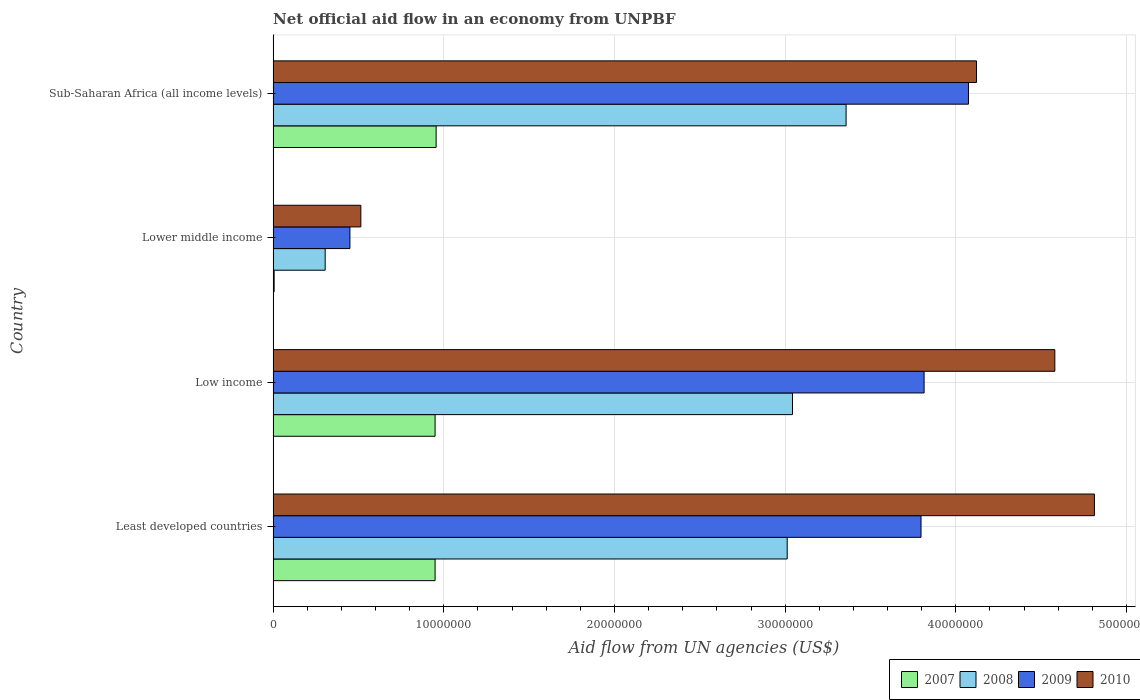How many groups of bars are there?
Your answer should be compact. 4. Are the number of bars per tick equal to the number of legend labels?
Offer a terse response. Yes. In how many cases, is the number of bars for a given country not equal to the number of legend labels?
Offer a very short reply. 0. What is the net official aid flow in 2008 in Least developed countries?
Your response must be concise. 3.01e+07. Across all countries, what is the maximum net official aid flow in 2007?
Provide a short and direct response. 9.55e+06. In which country was the net official aid flow in 2008 maximum?
Offer a terse response. Sub-Saharan Africa (all income levels). In which country was the net official aid flow in 2007 minimum?
Ensure brevity in your answer.  Lower middle income. What is the total net official aid flow in 2007 in the graph?
Your answer should be very brief. 2.86e+07. What is the difference between the net official aid flow in 2009 in Low income and that in Sub-Saharan Africa (all income levels)?
Make the answer very short. -2.60e+06. What is the difference between the net official aid flow in 2007 in Least developed countries and the net official aid flow in 2009 in Low income?
Your response must be concise. -2.86e+07. What is the average net official aid flow in 2010 per country?
Your answer should be very brief. 3.51e+07. What is the difference between the net official aid flow in 2007 and net official aid flow in 2008 in Sub-Saharan Africa (all income levels)?
Make the answer very short. -2.40e+07. What is the ratio of the net official aid flow in 2010 in Least developed countries to that in Lower middle income?
Offer a terse response. 9.36. Is the net official aid flow in 2007 in Least developed countries less than that in Sub-Saharan Africa (all income levels)?
Give a very brief answer. Yes. Is the difference between the net official aid flow in 2007 in Least developed countries and Sub-Saharan Africa (all income levels) greater than the difference between the net official aid flow in 2008 in Least developed countries and Sub-Saharan Africa (all income levels)?
Keep it short and to the point. Yes. What is the difference between the highest and the second highest net official aid flow in 2010?
Offer a terse response. 2.32e+06. What is the difference between the highest and the lowest net official aid flow in 2009?
Offer a terse response. 3.62e+07. In how many countries, is the net official aid flow in 2010 greater than the average net official aid flow in 2010 taken over all countries?
Offer a terse response. 3. Is it the case that in every country, the sum of the net official aid flow in 2009 and net official aid flow in 2010 is greater than the sum of net official aid flow in 2008 and net official aid flow in 2007?
Give a very brief answer. No. What does the 2nd bar from the bottom in Least developed countries represents?
Offer a very short reply. 2008. Is it the case that in every country, the sum of the net official aid flow in 2009 and net official aid flow in 2010 is greater than the net official aid flow in 2008?
Provide a short and direct response. Yes. How many countries are there in the graph?
Your answer should be compact. 4. What is the difference between two consecutive major ticks on the X-axis?
Your answer should be compact. 1.00e+07. Does the graph contain grids?
Make the answer very short. Yes. How many legend labels are there?
Ensure brevity in your answer.  4. How are the legend labels stacked?
Your answer should be compact. Horizontal. What is the title of the graph?
Your answer should be compact. Net official aid flow in an economy from UNPBF. Does "1969" appear as one of the legend labels in the graph?
Make the answer very short. No. What is the label or title of the X-axis?
Offer a terse response. Aid flow from UN agencies (US$). What is the Aid flow from UN agencies (US$) of 2007 in Least developed countries?
Provide a succinct answer. 9.49e+06. What is the Aid flow from UN agencies (US$) of 2008 in Least developed countries?
Your response must be concise. 3.01e+07. What is the Aid flow from UN agencies (US$) of 2009 in Least developed countries?
Offer a very short reply. 3.80e+07. What is the Aid flow from UN agencies (US$) in 2010 in Least developed countries?
Your answer should be very brief. 4.81e+07. What is the Aid flow from UN agencies (US$) of 2007 in Low income?
Offer a very short reply. 9.49e+06. What is the Aid flow from UN agencies (US$) of 2008 in Low income?
Offer a very short reply. 3.04e+07. What is the Aid flow from UN agencies (US$) in 2009 in Low income?
Offer a terse response. 3.81e+07. What is the Aid flow from UN agencies (US$) in 2010 in Low income?
Your response must be concise. 4.58e+07. What is the Aid flow from UN agencies (US$) of 2007 in Lower middle income?
Make the answer very short. 6.00e+04. What is the Aid flow from UN agencies (US$) of 2008 in Lower middle income?
Offer a terse response. 3.05e+06. What is the Aid flow from UN agencies (US$) in 2009 in Lower middle income?
Provide a short and direct response. 4.50e+06. What is the Aid flow from UN agencies (US$) in 2010 in Lower middle income?
Your response must be concise. 5.14e+06. What is the Aid flow from UN agencies (US$) in 2007 in Sub-Saharan Africa (all income levels)?
Keep it short and to the point. 9.55e+06. What is the Aid flow from UN agencies (US$) of 2008 in Sub-Saharan Africa (all income levels)?
Give a very brief answer. 3.36e+07. What is the Aid flow from UN agencies (US$) in 2009 in Sub-Saharan Africa (all income levels)?
Provide a succinct answer. 4.07e+07. What is the Aid flow from UN agencies (US$) of 2010 in Sub-Saharan Africa (all income levels)?
Offer a very short reply. 4.12e+07. Across all countries, what is the maximum Aid flow from UN agencies (US$) in 2007?
Your answer should be very brief. 9.55e+06. Across all countries, what is the maximum Aid flow from UN agencies (US$) in 2008?
Provide a short and direct response. 3.36e+07. Across all countries, what is the maximum Aid flow from UN agencies (US$) of 2009?
Give a very brief answer. 4.07e+07. Across all countries, what is the maximum Aid flow from UN agencies (US$) in 2010?
Keep it short and to the point. 4.81e+07. Across all countries, what is the minimum Aid flow from UN agencies (US$) of 2007?
Provide a succinct answer. 6.00e+04. Across all countries, what is the minimum Aid flow from UN agencies (US$) of 2008?
Give a very brief answer. 3.05e+06. Across all countries, what is the minimum Aid flow from UN agencies (US$) in 2009?
Your answer should be very brief. 4.50e+06. Across all countries, what is the minimum Aid flow from UN agencies (US$) of 2010?
Give a very brief answer. 5.14e+06. What is the total Aid flow from UN agencies (US$) in 2007 in the graph?
Give a very brief answer. 2.86e+07. What is the total Aid flow from UN agencies (US$) of 2008 in the graph?
Your response must be concise. 9.72e+07. What is the total Aid flow from UN agencies (US$) of 2009 in the graph?
Keep it short and to the point. 1.21e+08. What is the total Aid flow from UN agencies (US$) in 2010 in the graph?
Provide a short and direct response. 1.40e+08. What is the difference between the Aid flow from UN agencies (US$) of 2008 in Least developed countries and that in Low income?
Your answer should be compact. -3.10e+05. What is the difference between the Aid flow from UN agencies (US$) in 2009 in Least developed countries and that in Low income?
Provide a short and direct response. -1.80e+05. What is the difference between the Aid flow from UN agencies (US$) of 2010 in Least developed countries and that in Low income?
Offer a terse response. 2.32e+06. What is the difference between the Aid flow from UN agencies (US$) of 2007 in Least developed countries and that in Lower middle income?
Offer a terse response. 9.43e+06. What is the difference between the Aid flow from UN agencies (US$) in 2008 in Least developed countries and that in Lower middle income?
Give a very brief answer. 2.71e+07. What is the difference between the Aid flow from UN agencies (US$) of 2009 in Least developed countries and that in Lower middle income?
Make the answer very short. 3.35e+07. What is the difference between the Aid flow from UN agencies (US$) in 2010 in Least developed countries and that in Lower middle income?
Provide a short and direct response. 4.30e+07. What is the difference between the Aid flow from UN agencies (US$) in 2007 in Least developed countries and that in Sub-Saharan Africa (all income levels)?
Provide a succinct answer. -6.00e+04. What is the difference between the Aid flow from UN agencies (US$) of 2008 in Least developed countries and that in Sub-Saharan Africa (all income levels)?
Provide a succinct answer. -3.45e+06. What is the difference between the Aid flow from UN agencies (US$) of 2009 in Least developed countries and that in Sub-Saharan Africa (all income levels)?
Your answer should be very brief. -2.78e+06. What is the difference between the Aid flow from UN agencies (US$) in 2010 in Least developed countries and that in Sub-Saharan Africa (all income levels)?
Provide a succinct answer. 6.91e+06. What is the difference between the Aid flow from UN agencies (US$) of 2007 in Low income and that in Lower middle income?
Your answer should be very brief. 9.43e+06. What is the difference between the Aid flow from UN agencies (US$) of 2008 in Low income and that in Lower middle income?
Provide a succinct answer. 2.74e+07. What is the difference between the Aid flow from UN agencies (US$) of 2009 in Low income and that in Lower middle income?
Provide a short and direct response. 3.36e+07. What is the difference between the Aid flow from UN agencies (US$) in 2010 in Low income and that in Lower middle income?
Give a very brief answer. 4.07e+07. What is the difference between the Aid flow from UN agencies (US$) in 2008 in Low income and that in Sub-Saharan Africa (all income levels)?
Your answer should be compact. -3.14e+06. What is the difference between the Aid flow from UN agencies (US$) of 2009 in Low income and that in Sub-Saharan Africa (all income levels)?
Make the answer very short. -2.60e+06. What is the difference between the Aid flow from UN agencies (US$) in 2010 in Low income and that in Sub-Saharan Africa (all income levels)?
Offer a terse response. 4.59e+06. What is the difference between the Aid flow from UN agencies (US$) of 2007 in Lower middle income and that in Sub-Saharan Africa (all income levels)?
Your response must be concise. -9.49e+06. What is the difference between the Aid flow from UN agencies (US$) in 2008 in Lower middle income and that in Sub-Saharan Africa (all income levels)?
Ensure brevity in your answer.  -3.05e+07. What is the difference between the Aid flow from UN agencies (US$) in 2009 in Lower middle income and that in Sub-Saharan Africa (all income levels)?
Provide a succinct answer. -3.62e+07. What is the difference between the Aid flow from UN agencies (US$) in 2010 in Lower middle income and that in Sub-Saharan Africa (all income levels)?
Offer a very short reply. -3.61e+07. What is the difference between the Aid flow from UN agencies (US$) of 2007 in Least developed countries and the Aid flow from UN agencies (US$) of 2008 in Low income?
Give a very brief answer. -2.09e+07. What is the difference between the Aid flow from UN agencies (US$) in 2007 in Least developed countries and the Aid flow from UN agencies (US$) in 2009 in Low income?
Provide a succinct answer. -2.86e+07. What is the difference between the Aid flow from UN agencies (US$) in 2007 in Least developed countries and the Aid flow from UN agencies (US$) in 2010 in Low income?
Offer a very short reply. -3.63e+07. What is the difference between the Aid flow from UN agencies (US$) of 2008 in Least developed countries and the Aid flow from UN agencies (US$) of 2009 in Low income?
Ensure brevity in your answer.  -8.02e+06. What is the difference between the Aid flow from UN agencies (US$) in 2008 in Least developed countries and the Aid flow from UN agencies (US$) in 2010 in Low income?
Your response must be concise. -1.57e+07. What is the difference between the Aid flow from UN agencies (US$) in 2009 in Least developed countries and the Aid flow from UN agencies (US$) in 2010 in Low income?
Provide a succinct answer. -7.84e+06. What is the difference between the Aid flow from UN agencies (US$) of 2007 in Least developed countries and the Aid flow from UN agencies (US$) of 2008 in Lower middle income?
Your answer should be very brief. 6.44e+06. What is the difference between the Aid flow from UN agencies (US$) in 2007 in Least developed countries and the Aid flow from UN agencies (US$) in 2009 in Lower middle income?
Your answer should be compact. 4.99e+06. What is the difference between the Aid flow from UN agencies (US$) of 2007 in Least developed countries and the Aid flow from UN agencies (US$) of 2010 in Lower middle income?
Provide a succinct answer. 4.35e+06. What is the difference between the Aid flow from UN agencies (US$) of 2008 in Least developed countries and the Aid flow from UN agencies (US$) of 2009 in Lower middle income?
Offer a terse response. 2.56e+07. What is the difference between the Aid flow from UN agencies (US$) in 2008 in Least developed countries and the Aid flow from UN agencies (US$) in 2010 in Lower middle income?
Your response must be concise. 2.50e+07. What is the difference between the Aid flow from UN agencies (US$) in 2009 in Least developed countries and the Aid flow from UN agencies (US$) in 2010 in Lower middle income?
Offer a terse response. 3.28e+07. What is the difference between the Aid flow from UN agencies (US$) in 2007 in Least developed countries and the Aid flow from UN agencies (US$) in 2008 in Sub-Saharan Africa (all income levels)?
Make the answer very short. -2.41e+07. What is the difference between the Aid flow from UN agencies (US$) of 2007 in Least developed countries and the Aid flow from UN agencies (US$) of 2009 in Sub-Saharan Africa (all income levels)?
Keep it short and to the point. -3.12e+07. What is the difference between the Aid flow from UN agencies (US$) of 2007 in Least developed countries and the Aid flow from UN agencies (US$) of 2010 in Sub-Saharan Africa (all income levels)?
Your answer should be compact. -3.17e+07. What is the difference between the Aid flow from UN agencies (US$) in 2008 in Least developed countries and the Aid flow from UN agencies (US$) in 2009 in Sub-Saharan Africa (all income levels)?
Provide a short and direct response. -1.06e+07. What is the difference between the Aid flow from UN agencies (US$) of 2008 in Least developed countries and the Aid flow from UN agencies (US$) of 2010 in Sub-Saharan Africa (all income levels)?
Make the answer very short. -1.11e+07. What is the difference between the Aid flow from UN agencies (US$) in 2009 in Least developed countries and the Aid flow from UN agencies (US$) in 2010 in Sub-Saharan Africa (all income levels)?
Your response must be concise. -3.25e+06. What is the difference between the Aid flow from UN agencies (US$) of 2007 in Low income and the Aid flow from UN agencies (US$) of 2008 in Lower middle income?
Your response must be concise. 6.44e+06. What is the difference between the Aid flow from UN agencies (US$) in 2007 in Low income and the Aid flow from UN agencies (US$) in 2009 in Lower middle income?
Offer a terse response. 4.99e+06. What is the difference between the Aid flow from UN agencies (US$) in 2007 in Low income and the Aid flow from UN agencies (US$) in 2010 in Lower middle income?
Keep it short and to the point. 4.35e+06. What is the difference between the Aid flow from UN agencies (US$) in 2008 in Low income and the Aid flow from UN agencies (US$) in 2009 in Lower middle income?
Your answer should be compact. 2.59e+07. What is the difference between the Aid flow from UN agencies (US$) of 2008 in Low income and the Aid flow from UN agencies (US$) of 2010 in Lower middle income?
Offer a terse response. 2.53e+07. What is the difference between the Aid flow from UN agencies (US$) of 2009 in Low income and the Aid flow from UN agencies (US$) of 2010 in Lower middle income?
Provide a succinct answer. 3.30e+07. What is the difference between the Aid flow from UN agencies (US$) in 2007 in Low income and the Aid flow from UN agencies (US$) in 2008 in Sub-Saharan Africa (all income levels)?
Provide a succinct answer. -2.41e+07. What is the difference between the Aid flow from UN agencies (US$) of 2007 in Low income and the Aid flow from UN agencies (US$) of 2009 in Sub-Saharan Africa (all income levels)?
Give a very brief answer. -3.12e+07. What is the difference between the Aid flow from UN agencies (US$) of 2007 in Low income and the Aid flow from UN agencies (US$) of 2010 in Sub-Saharan Africa (all income levels)?
Your response must be concise. -3.17e+07. What is the difference between the Aid flow from UN agencies (US$) in 2008 in Low income and the Aid flow from UN agencies (US$) in 2009 in Sub-Saharan Africa (all income levels)?
Your answer should be very brief. -1.03e+07. What is the difference between the Aid flow from UN agencies (US$) of 2008 in Low income and the Aid flow from UN agencies (US$) of 2010 in Sub-Saharan Africa (all income levels)?
Provide a succinct answer. -1.08e+07. What is the difference between the Aid flow from UN agencies (US$) in 2009 in Low income and the Aid flow from UN agencies (US$) in 2010 in Sub-Saharan Africa (all income levels)?
Your answer should be very brief. -3.07e+06. What is the difference between the Aid flow from UN agencies (US$) of 2007 in Lower middle income and the Aid flow from UN agencies (US$) of 2008 in Sub-Saharan Africa (all income levels)?
Your response must be concise. -3.35e+07. What is the difference between the Aid flow from UN agencies (US$) in 2007 in Lower middle income and the Aid flow from UN agencies (US$) in 2009 in Sub-Saharan Africa (all income levels)?
Your answer should be compact. -4.07e+07. What is the difference between the Aid flow from UN agencies (US$) in 2007 in Lower middle income and the Aid flow from UN agencies (US$) in 2010 in Sub-Saharan Africa (all income levels)?
Give a very brief answer. -4.12e+07. What is the difference between the Aid flow from UN agencies (US$) in 2008 in Lower middle income and the Aid flow from UN agencies (US$) in 2009 in Sub-Saharan Africa (all income levels)?
Make the answer very short. -3.77e+07. What is the difference between the Aid flow from UN agencies (US$) of 2008 in Lower middle income and the Aid flow from UN agencies (US$) of 2010 in Sub-Saharan Africa (all income levels)?
Make the answer very short. -3.82e+07. What is the difference between the Aid flow from UN agencies (US$) of 2009 in Lower middle income and the Aid flow from UN agencies (US$) of 2010 in Sub-Saharan Africa (all income levels)?
Keep it short and to the point. -3.67e+07. What is the average Aid flow from UN agencies (US$) in 2007 per country?
Provide a succinct answer. 7.15e+06. What is the average Aid flow from UN agencies (US$) in 2008 per country?
Make the answer very short. 2.43e+07. What is the average Aid flow from UN agencies (US$) in 2009 per country?
Keep it short and to the point. 3.03e+07. What is the average Aid flow from UN agencies (US$) of 2010 per country?
Offer a terse response. 3.51e+07. What is the difference between the Aid flow from UN agencies (US$) of 2007 and Aid flow from UN agencies (US$) of 2008 in Least developed countries?
Make the answer very short. -2.06e+07. What is the difference between the Aid flow from UN agencies (US$) in 2007 and Aid flow from UN agencies (US$) in 2009 in Least developed countries?
Your answer should be very brief. -2.85e+07. What is the difference between the Aid flow from UN agencies (US$) of 2007 and Aid flow from UN agencies (US$) of 2010 in Least developed countries?
Give a very brief answer. -3.86e+07. What is the difference between the Aid flow from UN agencies (US$) of 2008 and Aid flow from UN agencies (US$) of 2009 in Least developed countries?
Provide a succinct answer. -7.84e+06. What is the difference between the Aid flow from UN agencies (US$) in 2008 and Aid flow from UN agencies (US$) in 2010 in Least developed countries?
Keep it short and to the point. -1.80e+07. What is the difference between the Aid flow from UN agencies (US$) of 2009 and Aid flow from UN agencies (US$) of 2010 in Least developed countries?
Give a very brief answer. -1.02e+07. What is the difference between the Aid flow from UN agencies (US$) of 2007 and Aid flow from UN agencies (US$) of 2008 in Low income?
Your response must be concise. -2.09e+07. What is the difference between the Aid flow from UN agencies (US$) in 2007 and Aid flow from UN agencies (US$) in 2009 in Low income?
Offer a very short reply. -2.86e+07. What is the difference between the Aid flow from UN agencies (US$) of 2007 and Aid flow from UN agencies (US$) of 2010 in Low income?
Keep it short and to the point. -3.63e+07. What is the difference between the Aid flow from UN agencies (US$) in 2008 and Aid flow from UN agencies (US$) in 2009 in Low income?
Offer a very short reply. -7.71e+06. What is the difference between the Aid flow from UN agencies (US$) of 2008 and Aid flow from UN agencies (US$) of 2010 in Low income?
Your answer should be very brief. -1.54e+07. What is the difference between the Aid flow from UN agencies (US$) in 2009 and Aid flow from UN agencies (US$) in 2010 in Low income?
Provide a short and direct response. -7.66e+06. What is the difference between the Aid flow from UN agencies (US$) of 2007 and Aid flow from UN agencies (US$) of 2008 in Lower middle income?
Make the answer very short. -2.99e+06. What is the difference between the Aid flow from UN agencies (US$) in 2007 and Aid flow from UN agencies (US$) in 2009 in Lower middle income?
Your response must be concise. -4.44e+06. What is the difference between the Aid flow from UN agencies (US$) of 2007 and Aid flow from UN agencies (US$) of 2010 in Lower middle income?
Make the answer very short. -5.08e+06. What is the difference between the Aid flow from UN agencies (US$) in 2008 and Aid flow from UN agencies (US$) in 2009 in Lower middle income?
Ensure brevity in your answer.  -1.45e+06. What is the difference between the Aid flow from UN agencies (US$) of 2008 and Aid flow from UN agencies (US$) of 2010 in Lower middle income?
Ensure brevity in your answer.  -2.09e+06. What is the difference between the Aid flow from UN agencies (US$) of 2009 and Aid flow from UN agencies (US$) of 2010 in Lower middle income?
Ensure brevity in your answer.  -6.40e+05. What is the difference between the Aid flow from UN agencies (US$) in 2007 and Aid flow from UN agencies (US$) in 2008 in Sub-Saharan Africa (all income levels)?
Your response must be concise. -2.40e+07. What is the difference between the Aid flow from UN agencies (US$) in 2007 and Aid flow from UN agencies (US$) in 2009 in Sub-Saharan Africa (all income levels)?
Provide a succinct answer. -3.12e+07. What is the difference between the Aid flow from UN agencies (US$) of 2007 and Aid flow from UN agencies (US$) of 2010 in Sub-Saharan Africa (all income levels)?
Ensure brevity in your answer.  -3.17e+07. What is the difference between the Aid flow from UN agencies (US$) in 2008 and Aid flow from UN agencies (US$) in 2009 in Sub-Saharan Africa (all income levels)?
Offer a terse response. -7.17e+06. What is the difference between the Aid flow from UN agencies (US$) in 2008 and Aid flow from UN agencies (US$) in 2010 in Sub-Saharan Africa (all income levels)?
Offer a terse response. -7.64e+06. What is the difference between the Aid flow from UN agencies (US$) in 2009 and Aid flow from UN agencies (US$) in 2010 in Sub-Saharan Africa (all income levels)?
Offer a terse response. -4.70e+05. What is the ratio of the Aid flow from UN agencies (US$) in 2010 in Least developed countries to that in Low income?
Provide a succinct answer. 1.05. What is the ratio of the Aid flow from UN agencies (US$) in 2007 in Least developed countries to that in Lower middle income?
Offer a terse response. 158.17. What is the ratio of the Aid flow from UN agencies (US$) in 2008 in Least developed countries to that in Lower middle income?
Keep it short and to the point. 9.88. What is the ratio of the Aid flow from UN agencies (US$) of 2009 in Least developed countries to that in Lower middle income?
Keep it short and to the point. 8.44. What is the ratio of the Aid flow from UN agencies (US$) in 2010 in Least developed countries to that in Lower middle income?
Your answer should be compact. 9.36. What is the ratio of the Aid flow from UN agencies (US$) in 2008 in Least developed countries to that in Sub-Saharan Africa (all income levels)?
Provide a succinct answer. 0.9. What is the ratio of the Aid flow from UN agencies (US$) of 2009 in Least developed countries to that in Sub-Saharan Africa (all income levels)?
Your response must be concise. 0.93. What is the ratio of the Aid flow from UN agencies (US$) of 2010 in Least developed countries to that in Sub-Saharan Africa (all income levels)?
Give a very brief answer. 1.17. What is the ratio of the Aid flow from UN agencies (US$) in 2007 in Low income to that in Lower middle income?
Keep it short and to the point. 158.17. What is the ratio of the Aid flow from UN agencies (US$) of 2008 in Low income to that in Lower middle income?
Make the answer very short. 9.98. What is the ratio of the Aid flow from UN agencies (US$) in 2009 in Low income to that in Lower middle income?
Give a very brief answer. 8.48. What is the ratio of the Aid flow from UN agencies (US$) of 2010 in Low income to that in Lower middle income?
Your response must be concise. 8.91. What is the ratio of the Aid flow from UN agencies (US$) of 2008 in Low income to that in Sub-Saharan Africa (all income levels)?
Ensure brevity in your answer.  0.91. What is the ratio of the Aid flow from UN agencies (US$) of 2009 in Low income to that in Sub-Saharan Africa (all income levels)?
Keep it short and to the point. 0.94. What is the ratio of the Aid flow from UN agencies (US$) of 2010 in Low income to that in Sub-Saharan Africa (all income levels)?
Give a very brief answer. 1.11. What is the ratio of the Aid flow from UN agencies (US$) of 2007 in Lower middle income to that in Sub-Saharan Africa (all income levels)?
Keep it short and to the point. 0.01. What is the ratio of the Aid flow from UN agencies (US$) in 2008 in Lower middle income to that in Sub-Saharan Africa (all income levels)?
Provide a short and direct response. 0.09. What is the ratio of the Aid flow from UN agencies (US$) in 2009 in Lower middle income to that in Sub-Saharan Africa (all income levels)?
Provide a succinct answer. 0.11. What is the ratio of the Aid flow from UN agencies (US$) in 2010 in Lower middle income to that in Sub-Saharan Africa (all income levels)?
Make the answer very short. 0.12. What is the difference between the highest and the second highest Aid flow from UN agencies (US$) in 2007?
Provide a succinct answer. 6.00e+04. What is the difference between the highest and the second highest Aid flow from UN agencies (US$) of 2008?
Your answer should be compact. 3.14e+06. What is the difference between the highest and the second highest Aid flow from UN agencies (US$) of 2009?
Provide a short and direct response. 2.60e+06. What is the difference between the highest and the second highest Aid flow from UN agencies (US$) of 2010?
Give a very brief answer. 2.32e+06. What is the difference between the highest and the lowest Aid flow from UN agencies (US$) of 2007?
Ensure brevity in your answer.  9.49e+06. What is the difference between the highest and the lowest Aid flow from UN agencies (US$) of 2008?
Offer a very short reply. 3.05e+07. What is the difference between the highest and the lowest Aid flow from UN agencies (US$) in 2009?
Offer a terse response. 3.62e+07. What is the difference between the highest and the lowest Aid flow from UN agencies (US$) of 2010?
Offer a very short reply. 4.30e+07. 